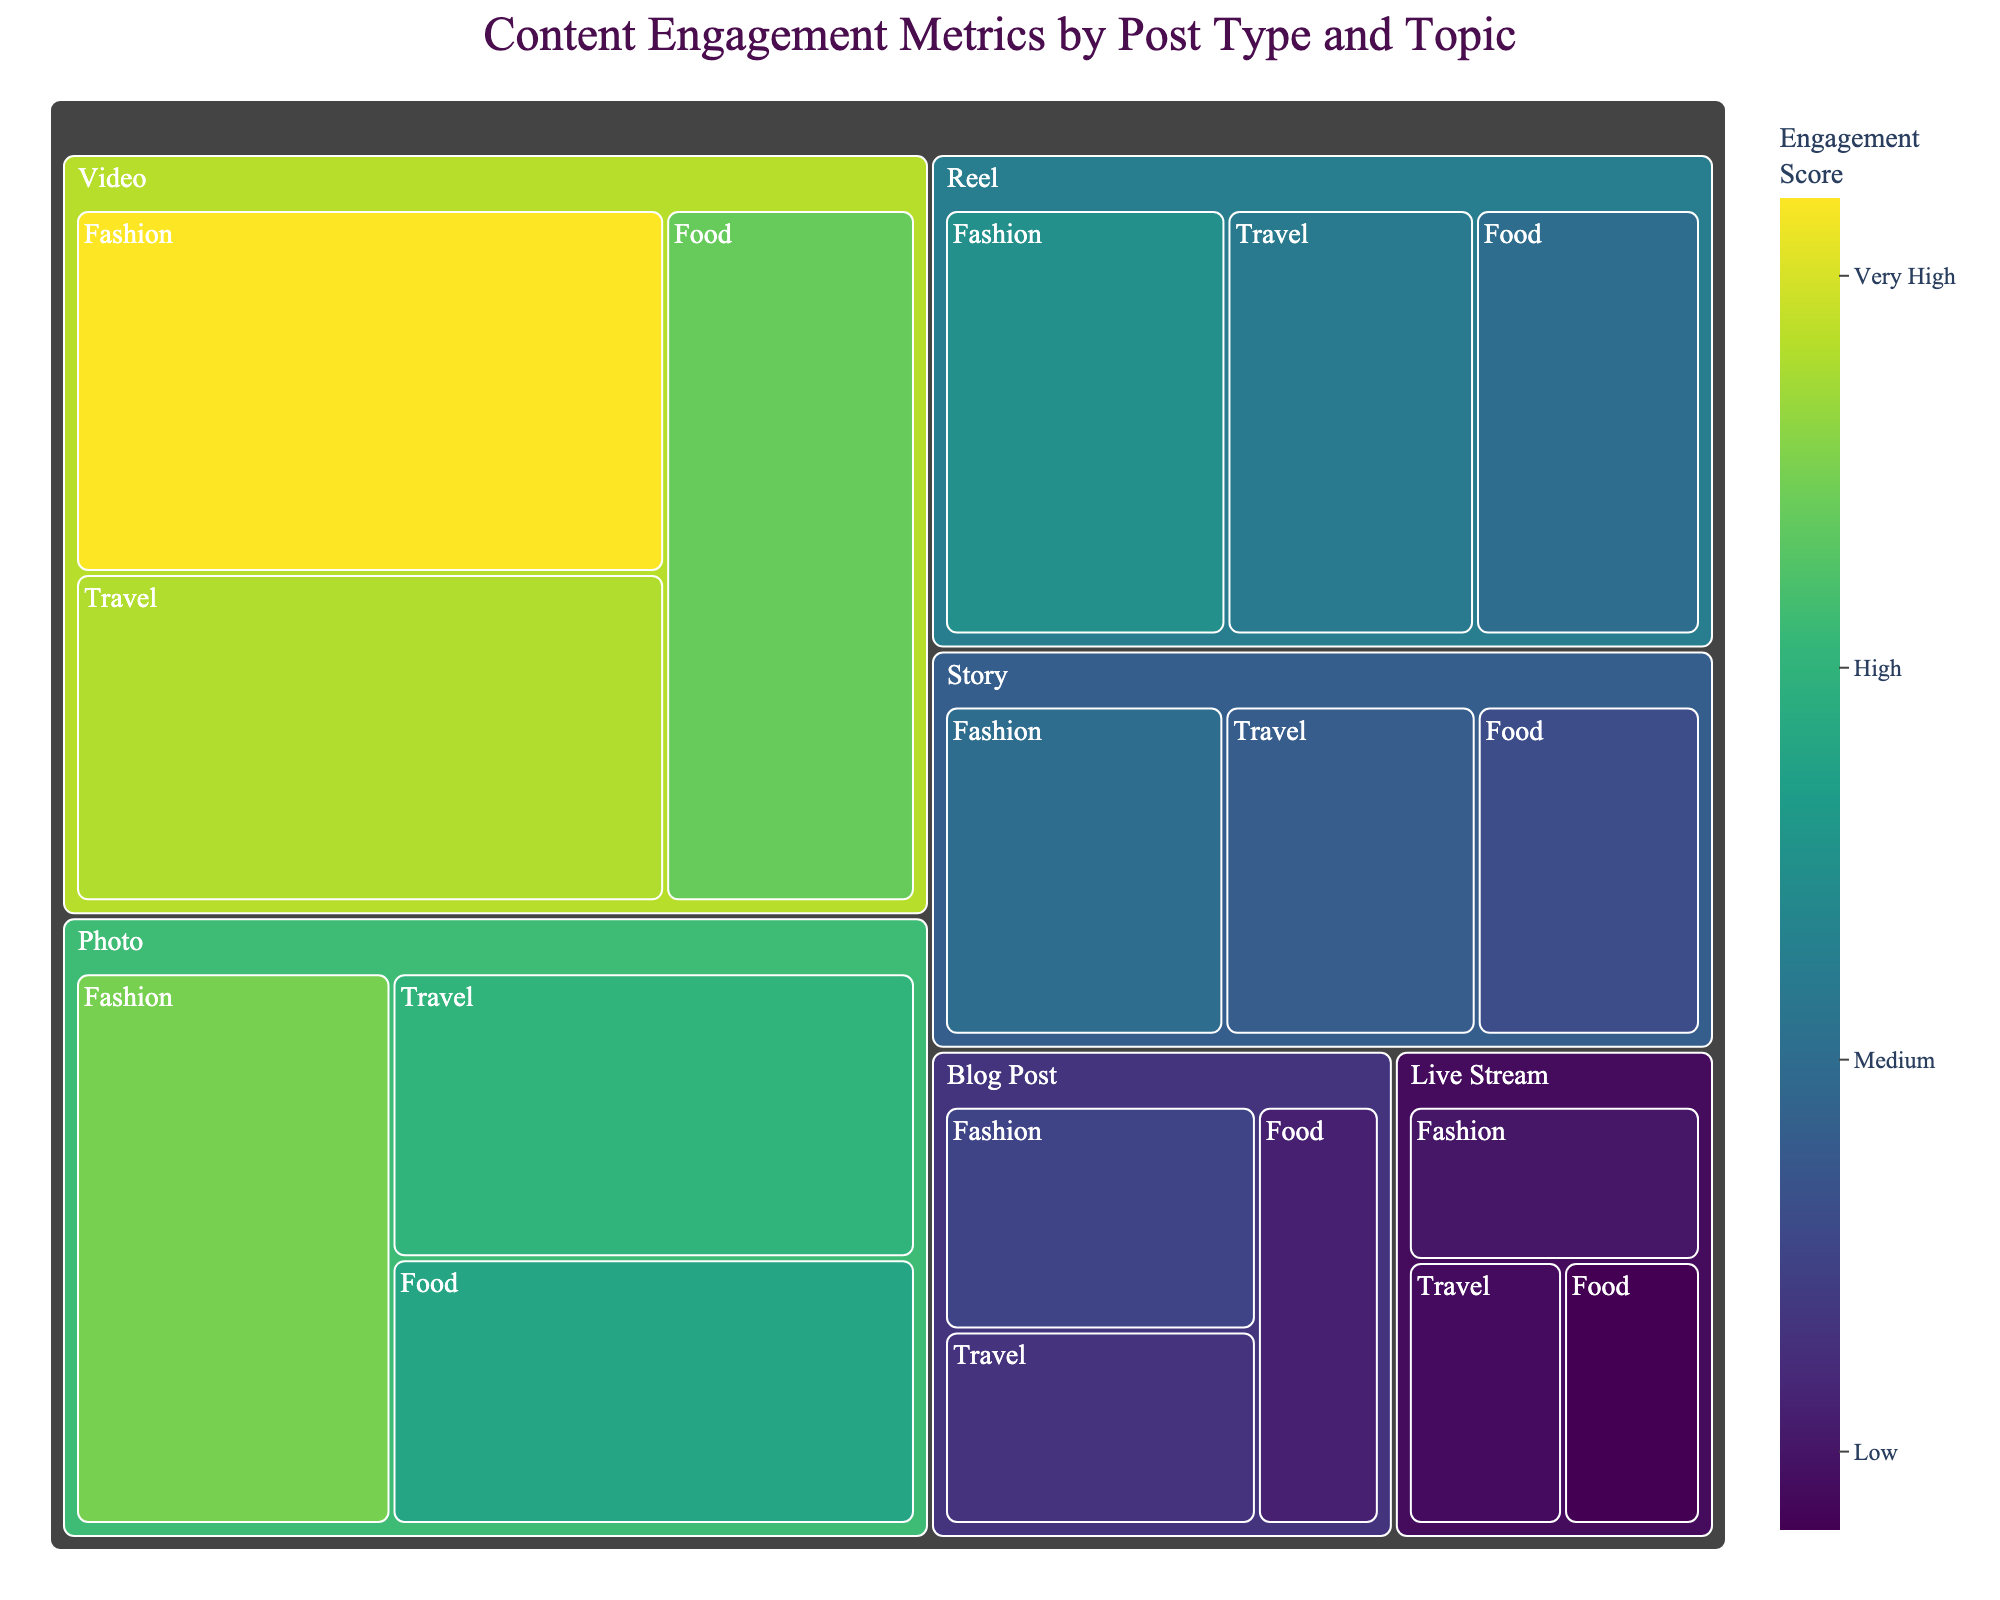How many different post types are represented in the treemap? Count the different "Post Type" labels in the treemap. There are six distinct post types: Photo, Video, Story, Blog Post, Live Stream, and Reel.
Answer: 6 Which post type has the highest total engagement score? Sum the engagement scores for each post type. "Photo" has scores 350, 300, and 280 which add up to 930, while "Video" has 420, 380, and 340 which add up to 1140. By summing the engagement scores of given post types, we find that ‘Video’ has the highest total engagement score
Answer: Video What is the total engagement score for the Fashion topic across all post types? Sum the engagement scores for the Fashion topic within each post type category: Photo (350) + Video (420) + Story (200) + Blog Post (150) + Live Stream (100) + Reel (250) = 1470
Answer: 1470 Among Travel posts, which post type has the lowest engagement score? Look at the engagement scores for Travel within each post type: Photo (300), Video (380), Story (180), Blog Post (130), Live Stream (90), and Reel (220). The lowest engagement score for Travel is Live Stream (90).
Answer: Live Stream Compare the engagement scores between the Video and Blog Post types. What is the difference in their total engagement scores? Sum the engagement scores for both post types: Video (420 + 380 + 340 = 1140), Blog Post (150 + 130 + 110 = 390). The difference is 1140 - 390 = 750.
Answer: 750 Which topic within the Photo post type has the highest engagement score? Look at the engagement scores for the Photo post type: Fashion (350), Travel (300), and Food (280). The highest engagement score is Fashion (350).
Answer: Fashion Is the engagement score for Food posts generally higher for videos or photos? Compare the engagement scores for Food posts in the Photo (280) and Video (340) post types. The engagement score is higher in Video (340).
Answer: Video What’s the total engagement score for Story and Live Stream post types combined? Sum the total engagement scores for both post types: Story (200 + 180 + 160 = 540) and Live Stream (100 + 90 + 80 = 270). The combined total is 540 + 270 = 810.
Answer: 810 Which post type has the least engagement in the Fashion topic? Check the engagement scores for the Fashion topic across all post types: Photo (350), Video (420), Story (200), Blog Post (150), Live Stream (100), Reel (250). The post type with the least engagement is Live Stream (100).
Answer: Live Stream Which topic shows the highest engagement score in the treemap? Look at all the engagement scores to identify the highest. The highest score is for the Fashion topic under the Video post type with an engagement score of 420.
Answer: Fashion under Video 